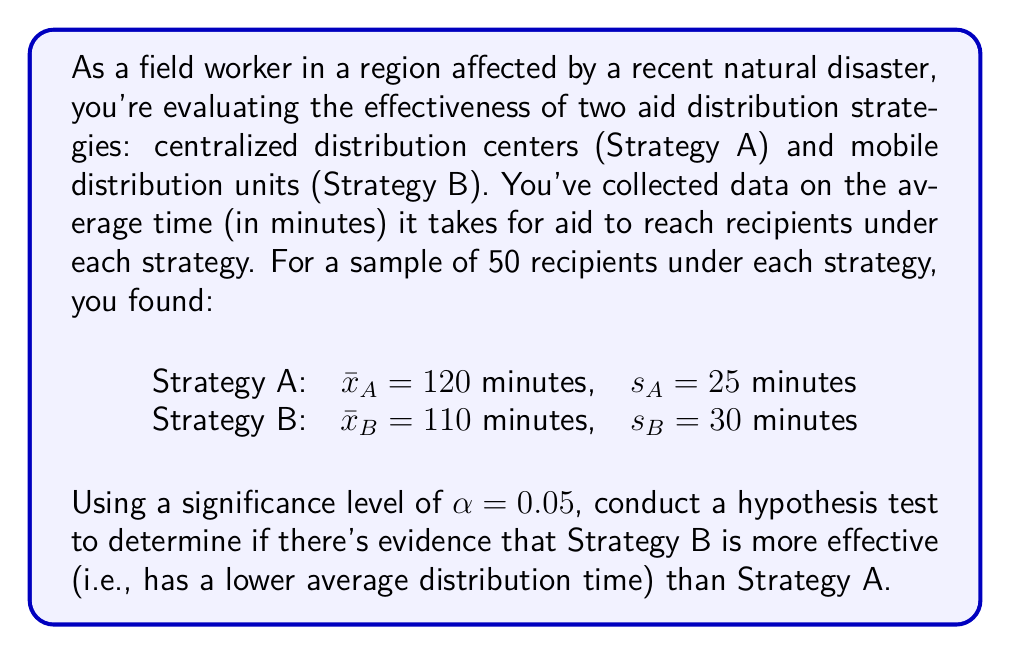Help me with this question. To evaluate the effectiveness of the two aid distribution strategies, we'll use a two-sample t-test for independent samples. We'll follow these steps:

1) First, let's state our hypotheses:
   $H_0: \mu_A \leq \mu_B$ (Strategy B is not more effective than Strategy A)
   $H_1: \mu_A > \mu_B$ (Strategy B is more effective than Strategy A)

2) We'll use a right-tailed test since we want to know if Strategy A's mean time is significantly greater than Strategy B's.

3) The test statistic for a two-sample t-test is:

   $$t = \frac{\bar{x}_A - \bar{x}_B}{\sqrt{\frac{s_A^2}{n_A} + \frac{s_B^2}{n_B}}}$$

   Where $n_A = n_B = 50$

4) Plugging in our values:

   $$t = \frac{120 - 110}{\sqrt{\frac{25^2}{50} + \frac{30^2}{50}}} = \frac{10}{\sqrt{12.5 + 18}} = \frac{10}{\sqrt{30.5}} \approx 1.81$$

5) The degrees of freedom for this test can be approximated using the Welch–Satterthwaite equation, but for simplicity, we'll use the conservative estimate of $df = min(n_A - 1, n_B - 1) = 49$.

6) For a right-tailed test with $\alpha = 0.05$ and $df = 49$, the critical t-value is approximately 1.677 (from a t-table or calculator).

7) Since our calculated t-value (1.81) is greater than the critical t-value (1.677), we reject the null hypothesis.

8) We can also calculate the p-value:
   $p-value = P(T > 1.81) \approx 0.0379$ (using a t-distribution calculator)

   Since $p-value < \alpha$, this also leads us to reject the null hypothesis.
Answer: Reject $H_0$. There is sufficient evidence at the 5% significance level to conclude that Strategy B (mobile distribution units) is more effective (has a lower average distribution time) than Strategy A (centralized distribution centers). 